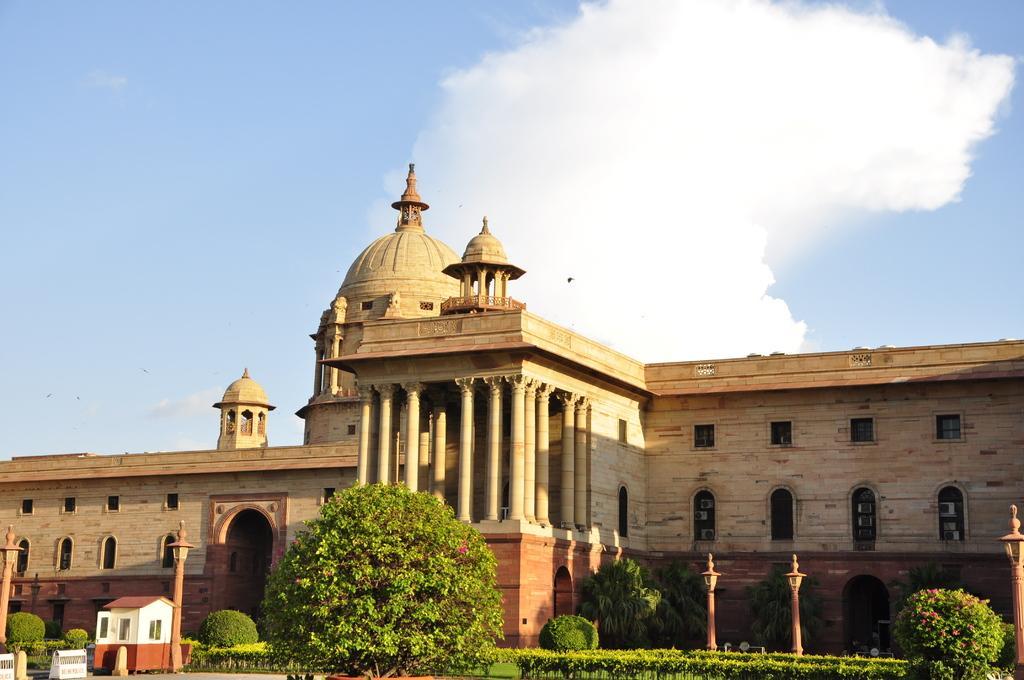How would you summarize this image in a sentence or two? At the bottom there are some plants and trees. In the background there is a building. At the top I can see the sky and clouds. 